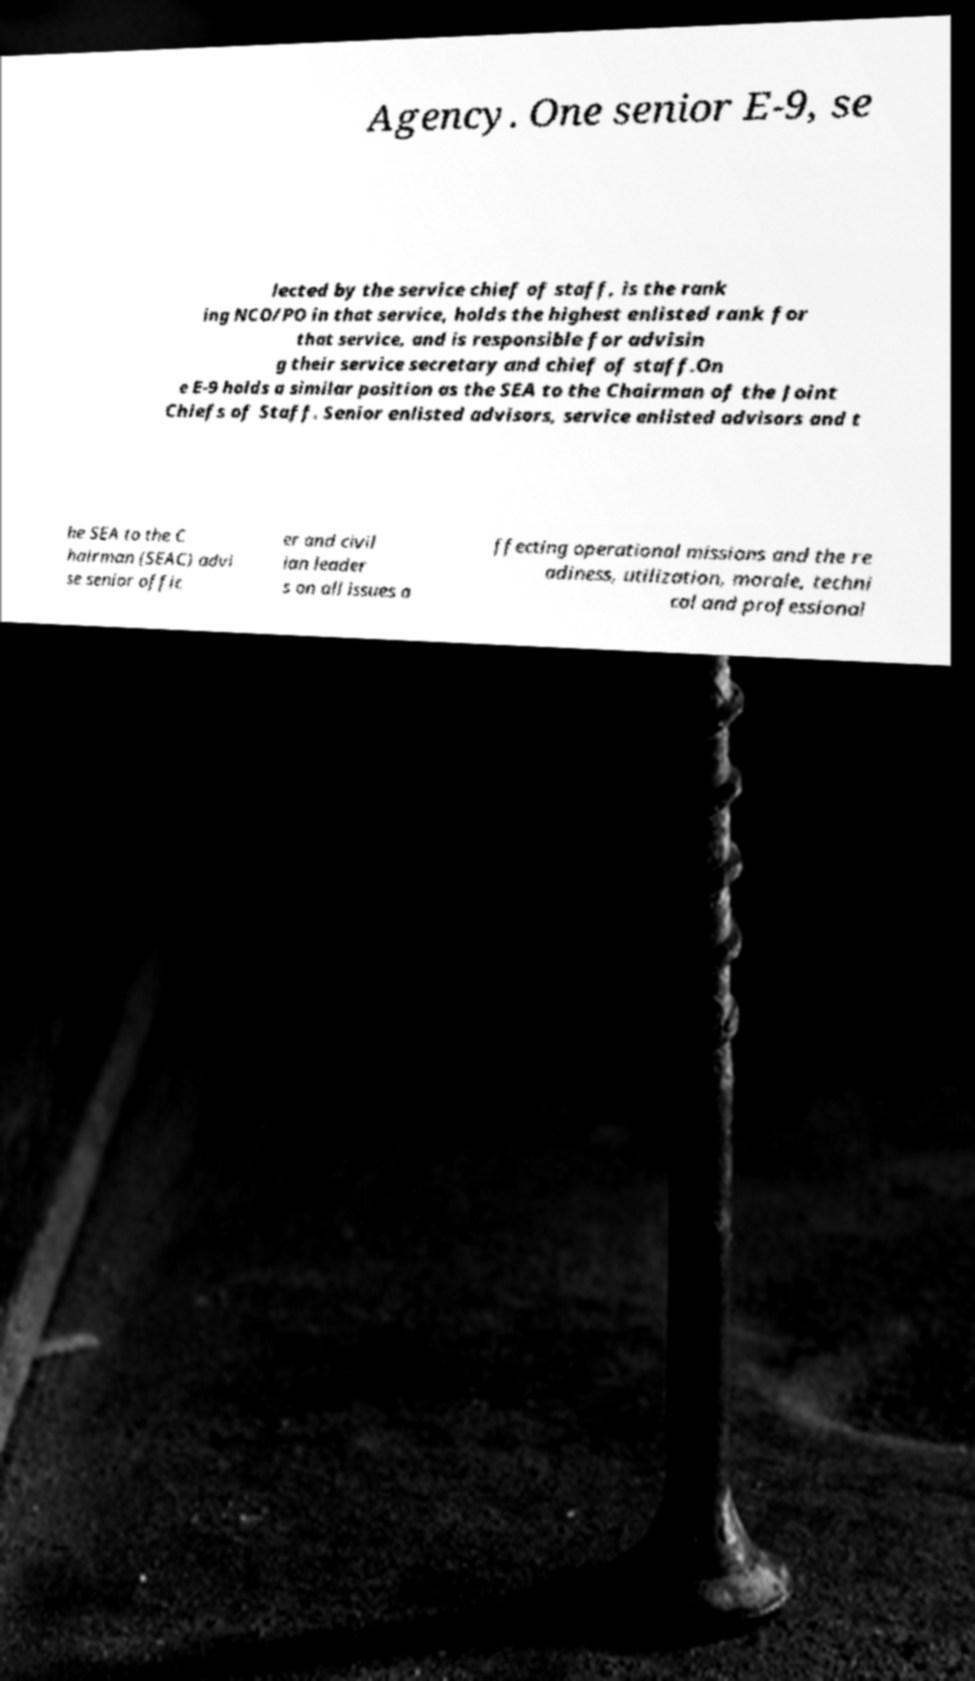For documentation purposes, I need the text within this image transcribed. Could you provide that? Agency. One senior E-9, se lected by the service chief of staff, is the rank ing NCO/PO in that service, holds the highest enlisted rank for that service, and is responsible for advisin g their service secretary and chief of staff.On e E-9 holds a similar position as the SEA to the Chairman of the Joint Chiefs of Staff. Senior enlisted advisors, service enlisted advisors and t he SEA to the C hairman (SEAC) advi se senior offic er and civil ian leader s on all issues a ffecting operational missions and the re adiness, utilization, morale, techni cal and professional 